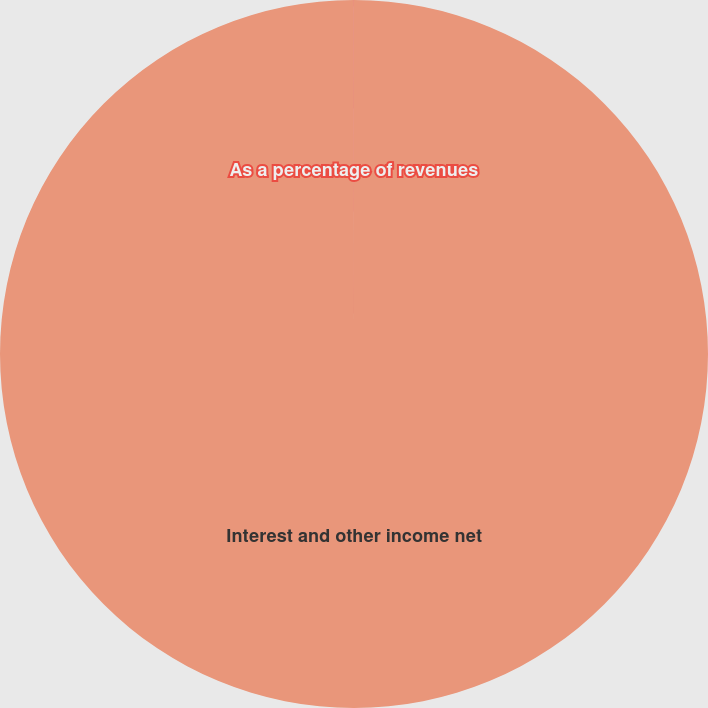Convert chart to OTSL. <chart><loc_0><loc_0><loc_500><loc_500><pie_chart><fcel>Interest and other income net<fcel>As a percentage of revenues<nl><fcel>99.99%<fcel>0.01%<nl></chart> 